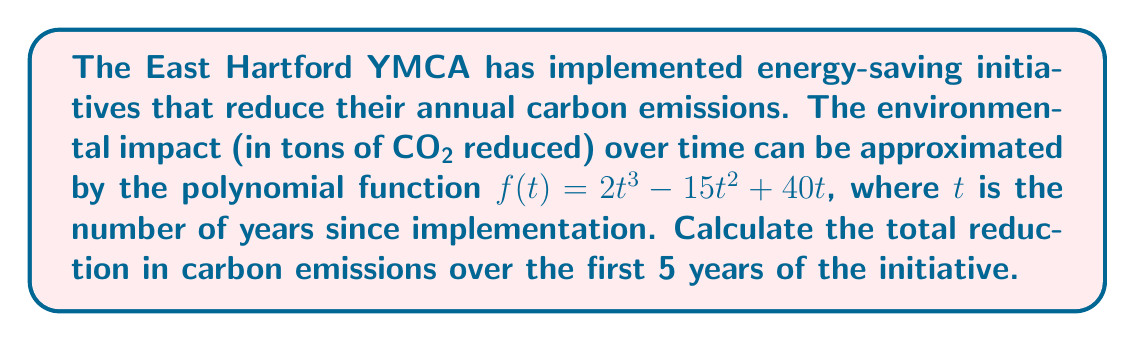Provide a solution to this math problem. To find the total reduction in carbon emissions over the first 5 years, we need to calculate the definite integral of the given function from $t=0$ to $t=5$.

1) The given function is $f(t) = 2t^3 - 15t^2 + 40t$

2) To integrate, we increase each exponent by 1 and divide by the new exponent:

   $$F(t) = \frac{2t^4}{4} - \frac{15t^3}{3} + \frac{40t^2}{2} + C$$
   
   $$F(t) = \frac{1}{2}t^4 - 5t^3 + 20t^2 + C$$

3) Now we calculate the definite integral from 0 to 5:

   $$\int_0^5 f(t) dt = F(5) - F(0)$$

4) Calculate $F(5)$:
   
   $$F(5) = \frac{1}{2}(5^4) - 5(5^3) + 20(5^2)$$
   $$= \frac{1}{2}(625) - 5(125) + 20(25)$$
   $$= 312.5 - 625 + 500 = 187.5$$

5) Calculate $F(0)$:
   
   $$F(0) = \frac{1}{2}(0^4) - 5(0^3) + 20(0^2) = 0$$

6) The definite integral is:

   $$\int_0^5 f(t) dt = F(5) - F(0) = 187.5 - 0 = 187.5$$

Therefore, the total reduction in carbon emissions over the first 5 years is 187.5 tons of CO2.
Answer: 187.5 tons of CO2 